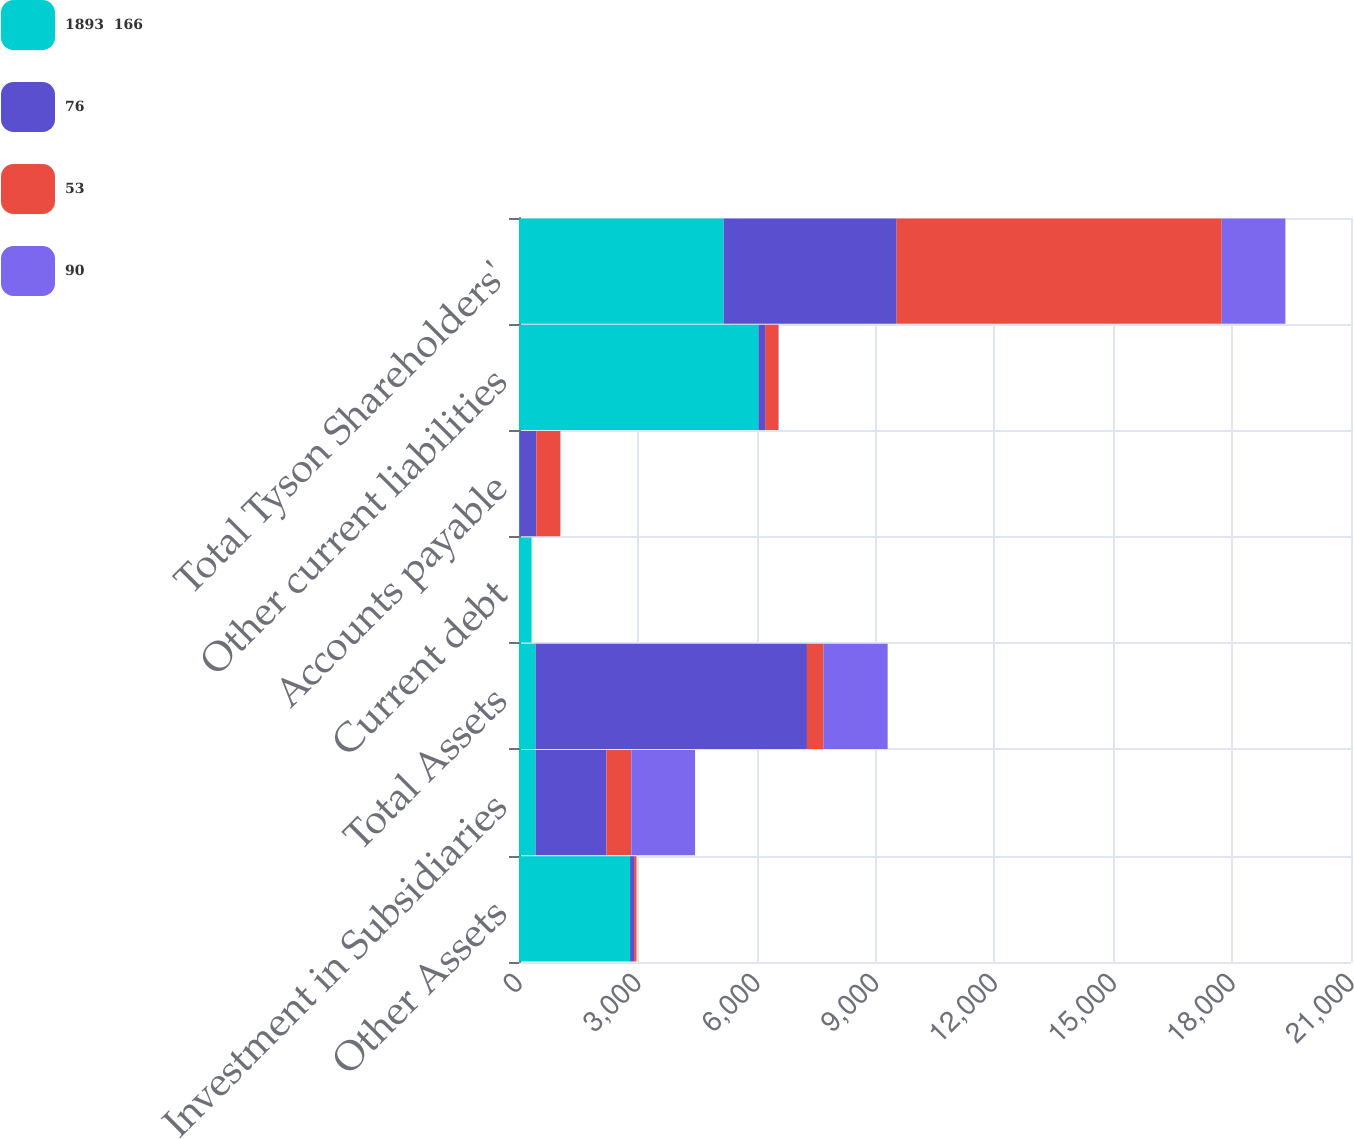<chart> <loc_0><loc_0><loc_500><loc_500><stacked_bar_chart><ecel><fcel>Other Assets<fcel>Investment in Subsidiaries<fcel>Total Assets<fcel>Current debt<fcel>Accounts payable<fcel>Other current liabilities<fcel>Total Tyson Shareholders'<nl><fcel>1893  166<fcel>2804<fcel>421<fcel>421<fcel>317<fcel>16<fcel>6044<fcel>5166<nl><fcel>76<fcel>101<fcel>1785<fcel>6847<fcel>0<fcel>421<fcel>168<fcel>4367<nl><fcel>53<fcel>61<fcel>631<fcel>421<fcel>0<fcel>608<fcel>335<fcel>8204<nl><fcel>90<fcel>0<fcel>1607<fcel>1616<fcel>0<fcel>0<fcel>9<fcel>1607<nl></chart> 